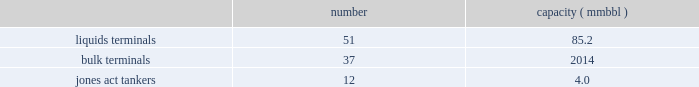In direct competition with other co2 pipelines .
We also compete with other interest owners in the mcelmo dome unit and the bravo dome unit for transportation of co2 to the denver city , texas market area .
Terminals our terminals segment includes the operations of our refined petroleum product , crude oil , chemical , ethanol and other liquid terminal facilities ( other than those included in the products pipelines segment ) and all of our coal , petroleum coke , fertilizer , steel , ores and other dry-bulk terminal facilities .
Our terminals are located throughout the u.s .
And in portions of canada .
We believe the location of our facilities and our ability to provide flexibility to customers help attract new and retain existing customers at our terminals and provide expansion opportunities .
We often classify our terminal operations based on the handling of either liquids or dry-bulk material products .
In addition , terminals 2019 marine operations include jones act qualified product tankers that provide marine transportation of crude oil , condensate and refined petroleum products in the u.s .
The following summarizes our terminals segment assets , as of december 31 , 2016 : number capacity ( mmbbl ) .
Competition we are one of the largest independent operators of liquids terminals in north america , based on barrels of liquids terminaling capacity .
Our liquids terminals compete with other publicly or privately held independent liquids terminals , and terminals owned by oil , chemical , pipeline , and refining companies .
Our bulk terminals compete with numerous independent terminal operators , terminals owned by producers and distributors of bulk commodities , stevedoring companies and other industrial companies opting not to outsource terminaling services .
In some locations , competitors are smaller , independent operators with lower cost structures .
Our jones act qualified product tankers compete with other jones act qualified vessel fleets. .
What is the average capacity in mmbbl of liquids terminals? 
Computations: (85.2 / 51)
Answer: 1.67059. 